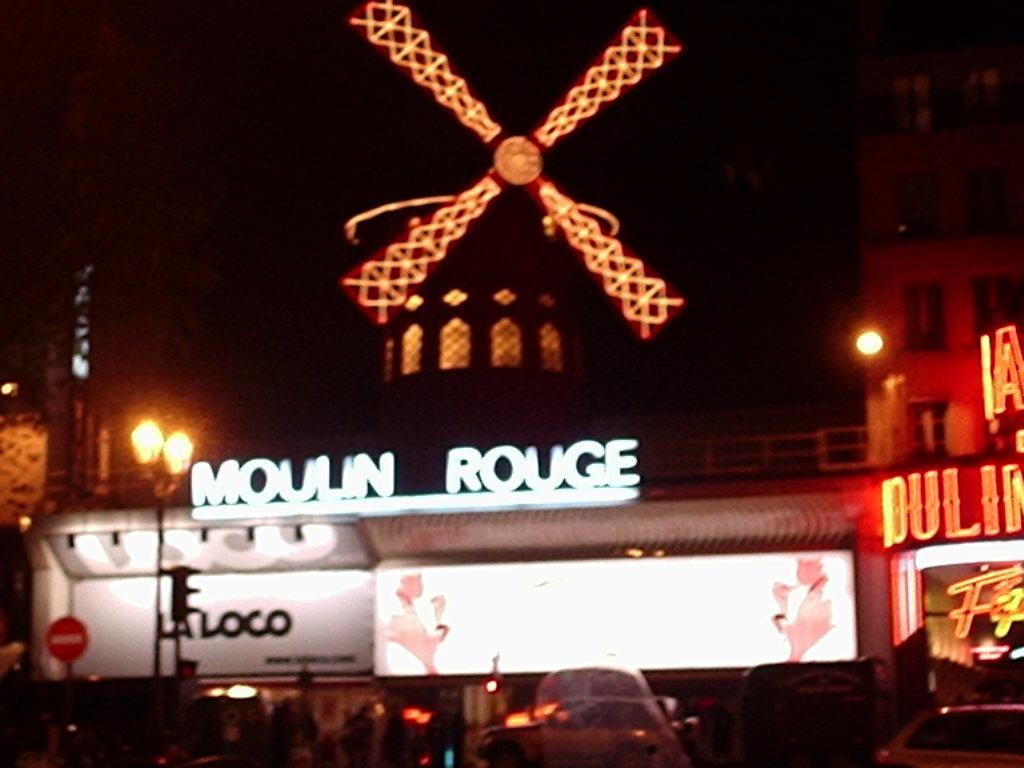In one or two sentences, can you explain what this image depicts? Here we can see buildings, boards, lights, and poles. There are cars. 